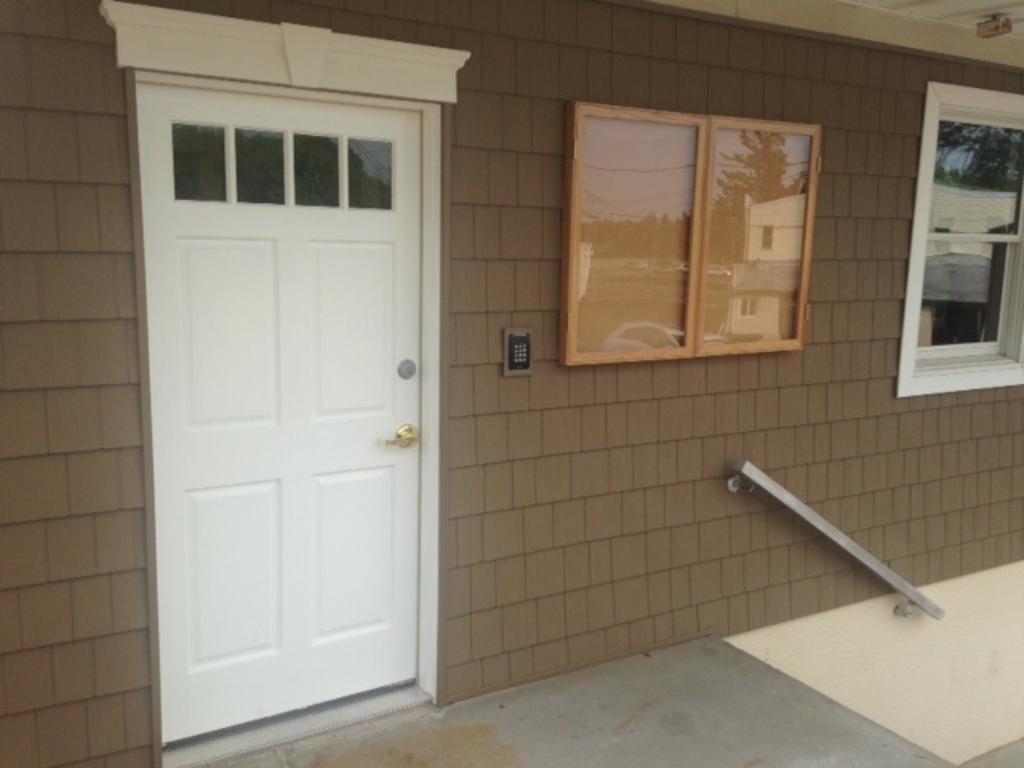How would you summarize this image in a sentence or two? This is a picture of a house. In the foreground of the picture there are door, board and window. In this picture there is a brick wall. 